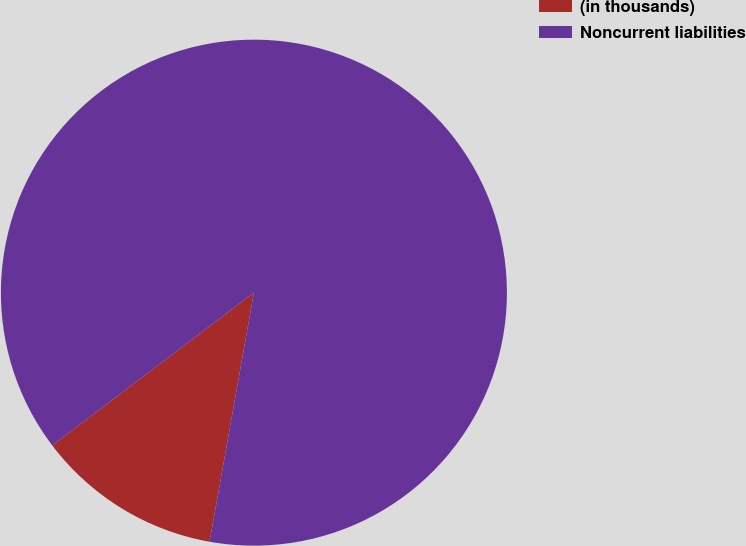Convert chart. <chart><loc_0><loc_0><loc_500><loc_500><pie_chart><fcel>(in thousands)<fcel>Noncurrent liabilities<nl><fcel>11.88%<fcel>88.12%<nl></chart> 